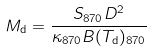<formula> <loc_0><loc_0><loc_500><loc_500>M _ { \mathrm d } = \frac { S _ { \mathrm 8 7 0 } D ^ { 2 } } { \kappa _ { \mathrm 8 7 0 } B ( T _ { \mathrm d } ) _ { \mathrm 8 7 0 } }</formula> 